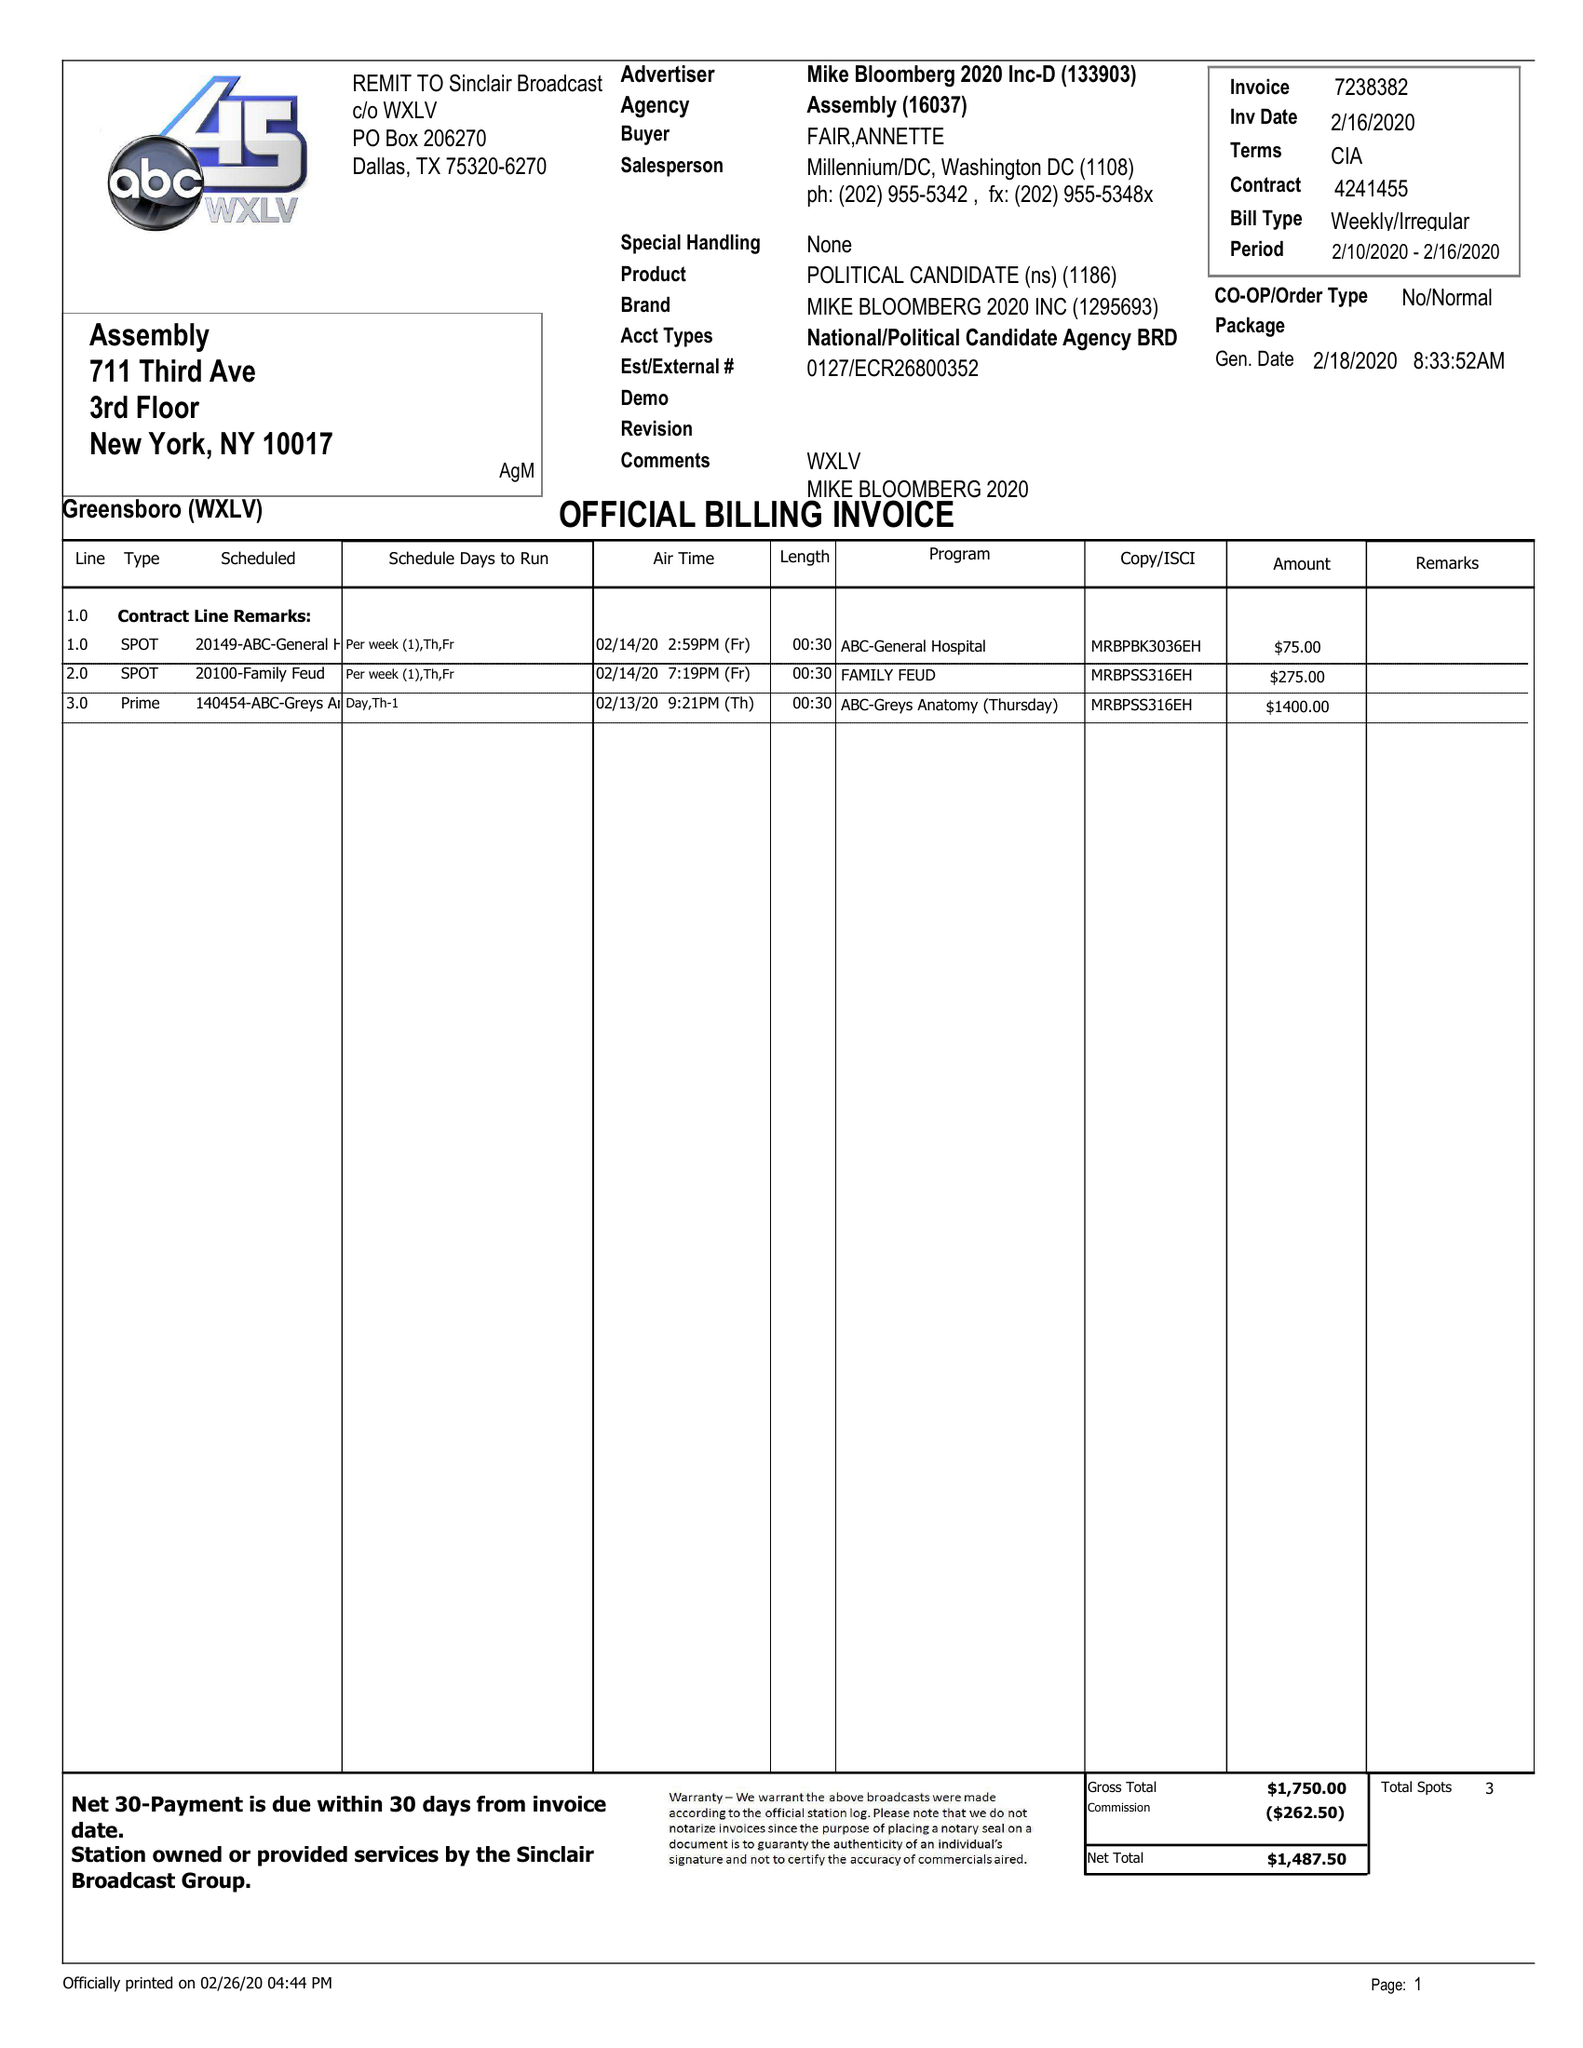What is the value for the contract_num?
Answer the question using a single word or phrase. 7238382 